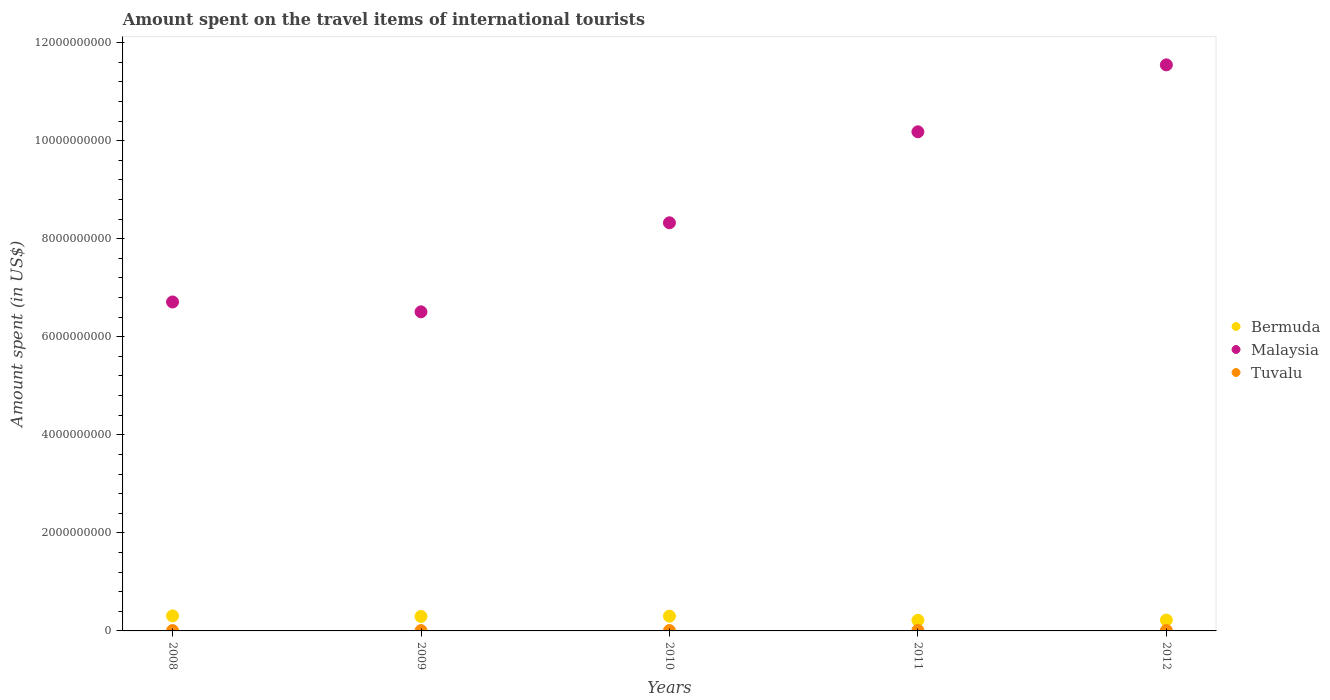How many different coloured dotlines are there?
Offer a very short reply. 3. Is the number of dotlines equal to the number of legend labels?
Provide a short and direct response. Yes. What is the amount spent on the travel items of international tourists in Bermuda in 2012?
Your answer should be very brief. 2.21e+08. Across all years, what is the maximum amount spent on the travel items of international tourists in Malaysia?
Provide a short and direct response. 1.15e+1. Across all years, what is the minimum amount spent on the travel items of international tourists in Bermuda?
Provide a short and direct response. 2.16e+08. In which year was the amount spent on the travel items of international tourists in Bermuda maximum?
Make the answer very short. 2008. In which year was the amount spent on the travel items of international tourists in Malaysia minimum?
Provide a short and direct response. 2009. What is the total amount spent on the travel items of international tourists in Bermuda in the graph?
Offer a very short reply. 1.34e+09. What is the difference between the amount spent on the travel items of international tourists in Tuvalu in 2010 and that in 2012?
Provide a succinct answer. -2.09e+06. What is the difference between the amount spent on the travel items of international tourists in Malaysia in 2011 and the amount spent on the travel items of international tourists in Tuvalu in 2010?
Provide a short and direct response. 1.02e+1. What is the average amount spent on the travel items of international tourists in Tuvalu per year?
Provide a short and direct response. 8.01e+06. In the year 2008, what is the difference between the amount spent on the travel items of international tourists in Tuvalu and amount spent on the travel items of international tourists in Malaysia?
Your answer should be very brief. -6.70e+09. In how many years, is the amount spent on the travel items of international tourists in Tuvalu greater than 400000000 US$?
Your answer should be compact. 0. What is the ratio of the amount spent on the travel items of international tourists in Malaysia in 2008 to that in 2010?
Offer a very short reply. 0.81. Is the difference between the amount spent on the travel items of international tourists in Tuvalu in 2008 and 2012 greater than the difference between the amount spent on the travel items of international tourists in Malaysia in 2008 and 2012?
Make the answer very short. Yes. What is the difference between the highest and the second highest amount spent on the travel items of international tourists in Malaysia?
Your answer should be very brief. 1.36e+09. What is the difference between the highest and the lowest amount spent on the travel items of international tourists in Malaysia?
Make the answer very short. 5.04e+09. Is the sum of the amount spent on the travel items of international tourists in Tuvalu in 2009 and 2012 greater than the maximum amount spent on the travel items of international tourists in Bermuda across all years?
Your answer should be compact. No. Does the amount spent on the travel items of international tourists in Tuvalu monotonically increase over the years?
Your answer should be very brief. No. Is the amount spent on the travel items of international tourists in Tuvalu strictly less than the amount spent on the travel items of international tourists in Bermuda over the years?
Your answer should be very brief. Yes. How many years are there in the graph?
Offer a very short reply. 5. What is the difference between two consecutive major ticks on the Y-axis?
Ensure brevity in your answer.  2.00e+09. Does the graph contain any zero values?
Your answer should be compact. No. How many legend labels are there?
Provide a succinct answer. 3. What is the title of the graph?
Offer a very short reply. Amount spent on the travel items of international tourists. Does "Northern Mariana Islands" appear as one of the legend labels in the graph?
Your answer should be very brief. No. What is the label or title of the X-axis?
Offer a terse response. Years. What is the label or title of the Y-axis?
Provide a succinct answer. Amount spent (in US$). What is the Amount spent (in US$) of Bermuda in 2008?
Your response must be concise. 3.07e+08. What is the Amount spent (in US$) in Malaysia in 2008?
Your answer should be very brief. 6.71e+09. What is the Amount spent (in US$) in Tuvalu in 2008?
Give a very brief answer. 7.23e+06. What is the Amount spent (in US$) in Bermuda in 2009?
Your response must be concise. 2.95e+08. What is the Amount spent (in US$) of Malaysia in 2009?
Give a very brief answer. 6.51e+09. What is the Amount spent (in US$) of Tuvalu in 2009?
Keep it short and to the point. 6.28e+06. What is the Amount spent (in US$) of Bermuda in 2010?
Provide a succinct answer. 3.01e+08. What is the Amount spent (in US$) in Malaysia in 2010?
Your answer should be very brief. 8.32e+09. What is the Amount spent (in US$) of Tuvalu in 2010?
Ensure brevity in your answer.  7.41e+06. What is the Amount spent (in US$) of Bermuda in 2011?
Offer a terse response. 2.16e+08. What is the Amount spent (in US$) in Malaysia in 2011?
Your response must be concise. 1.02e+1. What is the Amount spent (in US$) in Tuvalu in 2011?
Your response must be concise. 9.65e+06. What is the Amount spent (in US$) in Bermuda in 2012?
Provide a succinct answer. 2.21e+08. What is the Amount spent (in US$) in Malaysia in 2012?
Provide a succinct answer. 1.15e+1. What is the Amount spent (in US$) of Tuvalu in 2012?
Your response must be concise. 9.50e+06. Across all years, what is the maximum Amount spent (in US$) in Bermuda?
Give a very brief answer. 3.07e+08. Across all years, what is the maximum Amount spent (in US$) of Malaysia?
Give a very brief answer. 1.15e+1. Across all years, what is the maximum Amount spent (in US$) in Tuvalu?
Ensure brevity in your answer.  9.65e+06. Across all years, what is the minimum Amount spent (in US$) in Bermuda?
Ensure brevity in your answer.  2.16e+08. Across all years, what is the minimum Amount spent (in US$) in Malaysia?
Offer a terse response. 6.51e+09. Across all years, what is the minimum Amount spent (in US$) of Tuvalu?
Provide a succinct answer. 6.28e+06. What is the total Amount spent (in US$) of Bermuda in the graph?
Your answer should be compact. 1.34e+09. What is the total Amount spent (in US$) in Malaysia in the graph?
Provide a succinct answer. 4.33e+1. What is the total Amount spent (in US$) in Tuvalu in the graph?
Keep it short and to the point. 4.01e+07. What is the difference between the Amount spent (in US$) of Bermuda in 2008 and that in 2009?
Your answer should be compact. 1.20e+07. What is the difference between the Amount spent (in US$) of Malaysia in 2008 and that in 2009?
Give a very brief answer. 2.01e+08. What is the difference between the Amount spent (in US$) of Tuvalu in 2008 and that in 2009?
Give a very brief answer. 9.50e+05. What is the difference between the Amount spent (in US$) in Malaysia in 2008 and that in 2010?
Provide a succinct answer. -1.62e+09. What is the difference between the Amount spent (in US$) of Bermuda in 2008 and that in 2011?
Your answer should be compact. 9.10e+07. What is the difference between the Amount spent (in US$) of Malaysia in 2008 and that in 2011?
Your answer should be very brief. -3.47e+09. What is the difference between the Amount spent (in US$) in Tuvalu in 2008 and that in 2011?
Offer a terse response. -2.42e+06. What is the difference between the Amount spent (in US$) of Bermuda in 2008 and that in 2012?
Your response must be concise. 8.60e+07. What is the difference between the Amount spent (in US$) in Malaysia in 2008 and that in 2012?
Offer a terse response. -4.84e+09. What is the difference between the Amount spent (in US$) in Tuvalu in 2008 and that in 2012?
Ensure brevity in your answer.  -2.27e+06. What is the difference between the Amount spent (in US$) of Bermuda in 2009 and that in 2010?
Offer a very short reply. -6.00e+06. What is the difference between the Amount spent (in US$) in Malaysia in 2009 and that in 2010?
Ensure brevity in your answer.  -1.82e+09. What is the difference between the Amount spent (in US$) in Tuvalu in 2009 and that in 2010?
Offer a very short reply. -1.13e+06. What is the difference between the Amount spent (in US$) of Bermuda in 2009 and that in 2011?
Make the answer very short. 7.90e+07. What is the difference between the Amount spent (in US$) in Malaysia in 2009 and that in 2011?
Your response must be concise. -3.67e+09. What is the difference between the Amount spent (in US$) of Tuvalu in 2009 and that in 2011?
Make the answer very short. -3.37e+06. What is the difference between the Amount spent (in US$) of Bermuda in 2009 and that in 2012?
Make the answer very short. 7.40e+07. What is the difference between the Amount spent (in US$) of Malaysia in 2009 and that in 2012?
Offer a very short reply. -5.04e+09. What is the difference between the Amount spent (in US$) of Tuvalu in 2009 and that in 2012?
Offer a very short reply. -3.22e+06. What is the difference between the Amount spent (in US$) in Bermuda in 2010 and that in 2011?
Provide a short and direct response. 8.50e+07. What is the difference between the Amount spent (in US$) of Malaysia in 2010 and that in 2011?
Your response must be concise. -1.86e+09. What is the difference between the Amount spent (in US$) in Tuvalu in 2010 and that in 2011?
Provide a short and direct response. -2.24e+06. What is the difference between the Amount spent (in US$) in Bermuda in 2010 and that in 2012?
Offer a very short reply. 8.00e+07. What is the difference between the Amount spent (in US$) in Malaysia in 2010 and that in 2012?
Give a very brief answer. -3.22e+09. What is the difference between the Amount spent (in US$) of Tuvalu in 2010 and that in 2012?
Ensure brevity in your answer.  -2.09e+06. What is the difference between the Amount spent (in US$) in Bermuda in 2011 and that in 2012?
Ensure brevity in your answer.  -5.00e+06. What is the difference between the Amount spent (in US$) in Malaysia in 2011 and that in 2012?
Your answer should be compact. -1.36e+09. What is the difference between the Amount spent (in US$) of Tuvalu in 2011 and that in 2012?
Provide a succinct answer. 1.50e+05. What is the difference between the Amount spent (in US$) in Bermuda in 2008 and the Amount spent (in US$) in Malaysia in 2009?
Your answer should be very brief. -6.20e+09. What is the difference between the Amount spent (in US$) of Bermuda in 2008 and the Amount spent (in US$) of Tuvalu in 2009?
Keep it short and to the point. 3.01e+08. What is the difference between the Amount spent (in US$) in Malaysia in 2008 and the Amount spent (in US$) in Tuvalu in 2009?
Your answer should be very brief. 6.70e+09. What is the difference between the Amount spent (in US$) in Bermuda in 2008 and the Amount spent (in US$) in Malaysia in 2010?
Provide a succinct answer. -8.02e+09. What is the difference between the Amount spent (in US$) in Bermuda in 2008 and the Amount spent (in US$) in Tuvalu in 2010?
Your response must be concise. 3.00e+08. What is the difference between the Amount spent (in US$) in Malaysia in 2008 and the Amount spent (in US$) in Tuvalu in 2010?
Your answer should be compact. 6.70e+09. What is the difference between the Amount spent (in US$) of Bermuda in 2008 and the Amount spent (in US$) of Malaysia in 2011?
Keep it short and to the point. -9.87e+09. What is the difference between the Amount spent (in US$) of Bermuda in 2008 and the Amount spent (in US$) of Tuvalu in 2011?
Your answer should be very brief. 2.97e+08. What is the difference between the Amount spent (in US$) of Malaysia in 2008 and the Amount spent (in US$) of Tuvalu in 2011?
Offer a terse response. 6.70e+09. What is the difference between the Amount spent (in US$) of Bermuda in 2008 and the Amount spent (in US$) of Malaysia in 2012?
Your answer should be very brief. -1.12e+1. What is the difference between the Amount spent (in US$) of Bermuda in 2008 and the Amount spent (in US$) of Tuvalu in 2012?
Provide a succinct answer. 2.98e+08. What is the difference between the Amount spent (in US$) of Malaysia in 2008 and the Amount spent (in US$) of Tuvalu in 2012?
Your response must be concise. 6.70e+09. What is the difference between the Amount spent (in US$) in Bermuda in 2009 and the Amount spent (in US$) in Malaysia in 2010?
Provide a short and direct response. -8.03e+09. What is the difference between the Amount spent (in US$) of Bermuda in 2009 and the Amount spent (in US$) of Tuvalu in 2010?
Your answer should be compact. 2.88e+08. What is the difference between the Amount spent (in US$) in Malaysia in 2009 and the Amount spent (in US$) in Tuvalu in 2010?
Provide a short and direct response. 6.50e+09. What is the difference between the Amount spent (in US$) of Bermuda in 2009 and the Amount spent (in US$) of Malaysia in 2011?
Offer a very short reply. -9.88e+09. What is the difference between the Amount spent (in US$) of Bermuda in 2009 and the Amount spent (in US$) of Tuvalu in 2011?
Provide a short and direct response. 2.85e+08. What is the difference between the Amount spent (in US$) in Malaysia in 2009 and the Amount spent (in US$) in Tuvalu in 2011?
Give a very brief answer. 6.50e+09. What is the difference between the Amount spent (in US$) of Bermuda in 2009 and the Amount spent (in US$) of Malaysia in 2012?
Offer a terse response. -1.12e+1. What is the difference between the Amount spent (in US$) of Bermuda in 2009 and the Amount spent (in US$) of Tuvalu in 2012?
Your answer should be very brief. 2.86e+08. What is the difference between the Amount spent (in US$) of Malaysia in 2009 and the Amount spent (in US$) of Tuvalu in 2012?
Provide a succinct answer. 6.50e+09. What is the difference between the Amount spent (in US$) of Bermuda in 2010 and the Amount spent (in US$) of Malaysia in 2011?
Ensure brevity in your answer.  -9.88e+09. What is the difference between the Amount spent (in US$) in Bermuda in 2010 and the Amount spent (in US$) in Tuvalu in 2011?
Ensure brevity in your answer.  2.91e+08. What is the difference between the Amount spent (in US$) of Malaysia in 2010 and the Amount spent (in US$) of Tuvalu in 2011?
Keep it short and to the point. 8.31e+09. What is the difference between the Amount spent (in US$) in Bermuda in 2010 and the Amount spent (in US$) in Malaysia in 2012?
Ensure brevity in your answer.  -1.12e+1. What is the difference between the Amount spent (in US$) of Bermuda in 2010 and the Amount spent (in US$) of Tuvalu in 2012?
Give a very brief answer. 2.92e+08. What is the difference between the Amount spent (in US$) in Malaysia in 2010 and the Amount spent (in US$) in Tuvalu in 2012?
Give a very brief answer. 8.31e+09. What is the difference between the Amount spent (in US$) in Bermuda in 2011 and the Amount spent (in US$) in Malaysia in 2012?
Ensure brevity in your answer.  -1.13e+1. What is the difference between the Amount spent (in US$) in Bermuda in 2011 and the Amount spent (in US$) in Tuvalu in 2012?
Keep it short and to the point. 2.06e+08. What is the difference between the Amount spent (in US$) of Malaysia in 2011 and the Amount spent (in US$) of Tuvalu in 2012?
Your answer should be compact. 1.02e+1. What is the average Amount spent (in US$) of Bermuda per year?
Make the answer very short. 2.68e+08. What is the average Amount spent (in US$) in Malaysia per year?
Provide a short and direct response. 8.65e+09. What is the average Amount spent (in US$) in Tuvalu per year?
Provide a short and direct response. 8.01e+06. In the year 2008, what is the difference between the Amount spent (in US$) of Bermuda and Amount spent (in US$) of Malaysia?
Provide a short and direct response. -6.40e+09. In the year 2008, what is the difference between the Amount spent (in US$) in Bermuda and Amount spent (in US$) in Tuvalu?
Offer a very short reply. 3.00e+08. In the year 2008, what is the difference between the Amount spent (in US$) in Malaysia and Amount spent (in US$) in Tuvalu?
Your response must be concise. 6.70e+09. In the year 2009, what is the difference between the Amount spent (in US$) of Bermuda and Amount spent (in US$) of Malaysia?
Offer a terse response. -6.21e+09. In the year 2009, what is the difference between the Amount spent (in US$) in Bermuda and Amount spent (in US$) in Tuvalu?
Keep it short and to the point. 2.89e+08. In the year 2009, what is the difference between the Amount spent (in US$) in Malaysia and Amount spent (in US$) in Tuvalu?
Keep it short and to the point. 6.50e+09. In the year 2010, what is the difference between the Amount spent (in US$) in Bermuda and Amount spent (in US$) in Malaysia?
Your answer should be very brief. -8.02e+09. In the year 2010, what is the difference between the Amount spent (in US$) of Bermuda and Amount spent (in US$) of Tuvalu?
Make the answer very short. 2.94e+08. In the year 2010, what is the difference between the Amount spent (in US$) of Malaysia and Amount spent (in US$) of Tuvalu?
Your answer should be compact. 8.32e+09. In the year 2011, what is the difference between the Amount spent (in US$) of Bermuda and Amount spent (in US$) of Malaysia?
Ensure brevity in your answer.  -9.96e+09. In the year 2011, what is the difference between the Amount spent (in US$) of Bermuda and Amount spent (in US$) of Tuvalu?
Provide a short and direct response. 2.06e+08. In the year 2011, what is the difference between the Amount spent (in US$) in Malaysia and Amount spent (in US$) in Tuvalu?
Give a very brief answer. 1.02e+1. In the year 2012, what is the difference between the Amount spent (in US$) in Bermuda and Amount spent (in US$) in Malaysia?
Give a very brief answer. -1.13e+1. In the year 2012, what is the difference between the Amount spent (in US$) in Bermuda and Amount spent (in US$) in Tuvalu?
Offer a terse response. 2.12e+08. In the year 2012, what is the difference between the Amount spent (in US$) in Malaysia and Amount spent (in US$) in Tuvalu?
Your answer should be compact. 1.15e+1. What is the ratio of the Amount spent (in US$) in Bermuda in 2008 to that in 2009?
Offer a very short reply. 1.04. What is the ratio of the Amount spent (in US$) in Malaysia in 2008 to that in 2009?
Offer a terse response. 1.03. What is the ratio of the Amount spent (in US$) in Tuvalu in 2008 to that in 2009?
Your answer should be compact. 1.15. What is the ratio of the Amount spent (in US$) of Bermuda in 2008 to that in 2010?
Give a very brief answer. 1.02. What is the ratio of the Amount spent (in US$) in Malaysia in 2008 to that in 2010?
Ensure brevity in your answer.  0.81. What is the ratio of the Amount spent (in US$) in Tuvalu in 2008 to that in 2010?
Provide a succinct answer. 0.98. What is the ratio of the Amount spent (in US$) in Bermuda in 2008 to that in 2011?
Your answer should be compact. 1.42. What is the ratio of the Amount spent (in US$) of Malaysia in 2008 to that in 2011?
Your response must be concise. 0.66. What is the ratio of the Amount spent (in US$) in Tuvalu in 2008 to that in 2011?
Offer a terse response. 0.75. What is the ratio of the Amount spent (in US$) in Bermuda in 2008 to that in 2012?
Give a very brief answer. 1.39. What is the ratio of the Amount spent (in US$) of Malaysia in 2008 to that in 2012?
Keep it short and to the point. 0.58. What is the ratio of the Amount spent (in US$) of Tuvalu in 2008 to that in 2012?
Give a very brief answer. 0.76. What is the ratio of the Amount spent (in US$) in Bermuda in 2009 to that in 2010?
Your answer should be compact. 0.98. What is the ratio of the Amount spent (in US$) of Malaysia in 2009 to that in 2010?
Give a very brief answer. 0.78. What is the ratio of the Amount spent (in US$) of Tuvalu in 2009 to that in 2010?
Offer a terse response. 0.85. What is the ratio of the Amount spent (in US$) in Bermuda in 2009 to that in 2011?
Make the answer very short. 1.37. What is the ratio of the Amount spent (in US$) of Malaysia in 2009 to that in 2011?
Offer a very short reply. 0.64. What is the ratio of the Amount spent (in US$) in Tuvalu in 2009 to that in 2011?
Provide a succinct answer. 0.65. What is the ratio of the Amount spent (in US$) in Bermuda in 2009 to that in 2012?
Give a very brief answer. 1.33. What is the ratio of the Amount spent (in US$) in Malaysia in 2009 to that in 2012?
Make the answer very short. 0.56. What is the ratio of the Amount spent (in US$) of Tuvalu in 2009 to that in 2012?
Your response must be concise. 0.66. What is the ratio of the Amount spent (in US$) in Bermuda in 2010 to that in 2011?
Provide a succinct answer. 1.39. What is the ratio of the Amount spent (in US$) of Malaysia in 2010 to that in 2011?
Your response must be concise. 0.82. What is the ratio of the Amount spent (in US$) of Tuvalu in 2010 to that in 2011?
Give a very brief answer. 0.77. What is the ratio of the Amount spent (in US$) of Bermuda in 2010 to that in 2012?
Make the answer very short. 1.36. What is the ratio of the Amount spent (in US$) of Malaysia in 2010 to that in 2012?
Keep it short and to the point. 0.72. What is the ratio of the Amount spent (in US$) of Tuvalu in 2010 to that in 2012?
Provide a succinct answer. 0.78. What is the ratio of the Amount spent (in US$) of Bermuda in 2011 to that in 2012?
Your response must be concise. 0.98. What is the ratio of the Amount spent (in US$) in Malaysia in 2011 to that in 2012?
Your response must be concise. 0.88. What is the ratio of the Amount spent (in US$) of Tuvalu in 2011 to that in 2012?
Keep it short and to the point. 1.02. What is the difference between the highest and the second highest Amount spent (in US$) in Bermuda?
Ensure brevity in your answer.  6.00e+06. What is the difference between the highest and the second highest Amount spent (in US$) of Malaysia?
Your answer should be very brief. 1.36e+09. What is the difference between the highest and the second highest Amount spent (in US$) in Tuvalu?
Your answer should be compact. 1.50e+05. What is the difference between the highest and the lowest Amount spent (in US$) in Bermuda?
Provide a succinct answer. 9.10e+07. What is the difference between the highest and the lowest Amount spent (in US$) in Malaysia?
Your answer should be compact. 5.04e+09. What is the difference between the highest and the lowest Amount spent (in US$) of Tuvalu?
Your response must be concise. 3.37e+06. 